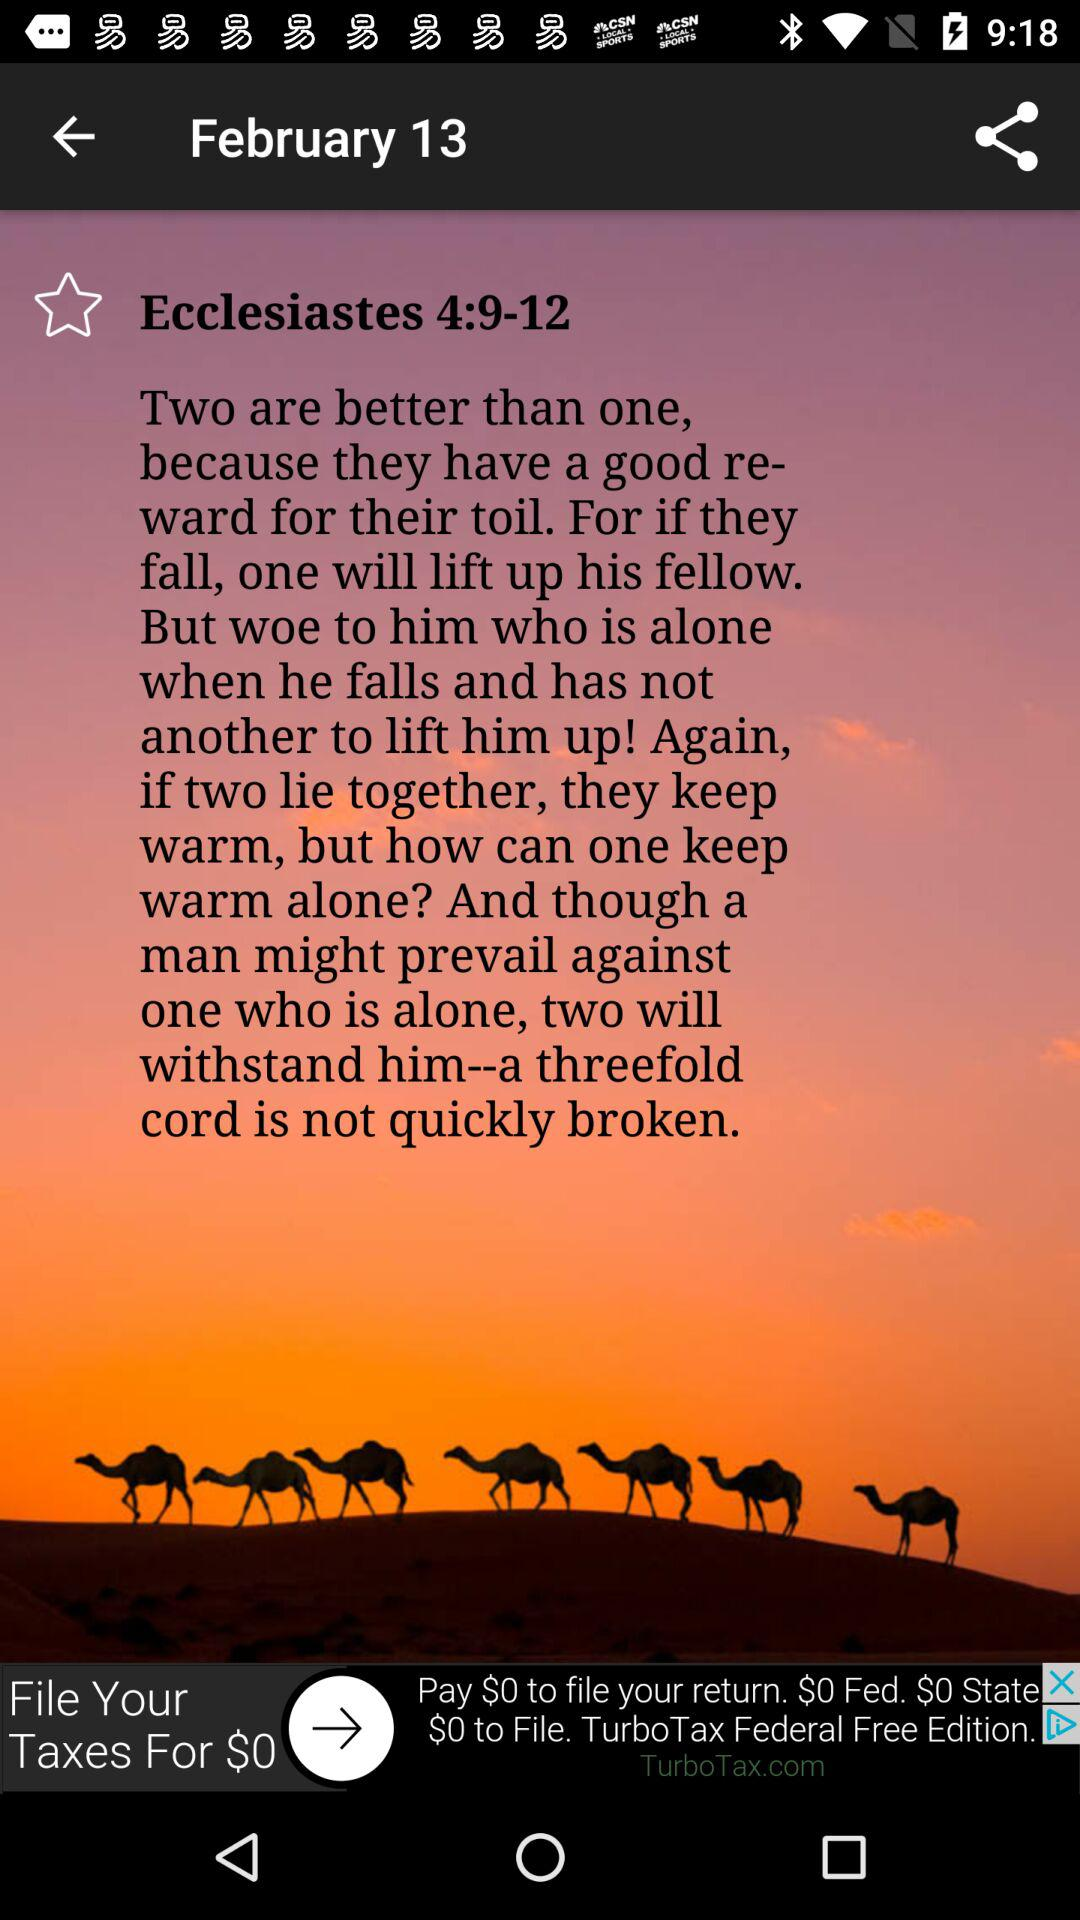What is the date? The date is February 13. 